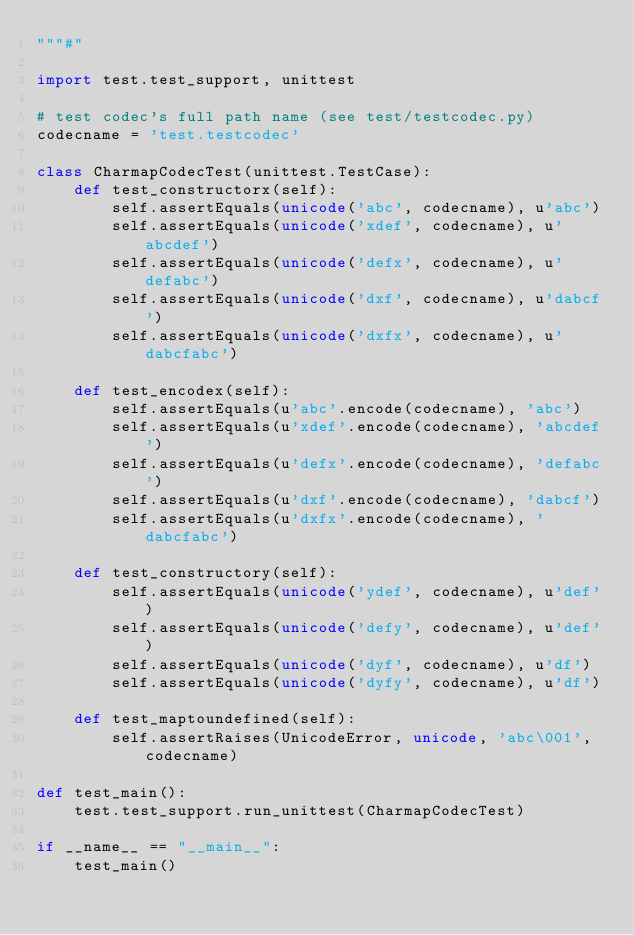<code> <loc_0><loc_0><loc_500><loc_500><_Python_>"""#"

import test.test_support, unittest

# test codec's full path name (see test/testcodec.py)
codecname = 'test.testcodec'

class CharmapCodecTest(unittest.TestCase):
    def test_constructorx(self):
        self.assertEquals(unicode('abc', codecname), u'abc')
        self.assertEquals(unicode('xdef', codecname), u'abcdef')
        self.assertEquals(unicode('defx', codecname), u'defabc')
        self.assertEquals(unicode('dxf', codecname), u'dabcf')
        self.assertEquals(unicode('dxfx', codecname), u'dabcfabc')

    def test_encodex(self):
        self.assertEquals(u'abc'.encode(codecname), 'abc')
        self.assertEquals(u'xdef'.encode(codecname), 'abcdef')
        self.assertEquals(u'defx'.encode(codecname), 'defabc')
        self.assertEquals(u'dxf'.encode(codecname), 'dabcf')
        self.assertEquals(u'dxfx'.encode(codecname), 'dabcfabc')

    def test_constructory(self):
        self.assertEquals(unicode('ydef', codecname), u'def')
        self.assertEquals(unicode('defy', codecname), u'def')
        self.assertEquals(unicode('dyf', codecname), u'df')
        self.assertEquals(unicode('dyfy', codecname), u'df')

    def test_maptoundefined(self):
        self.assertRaises(UnicodeError, unicode, 'abc\001', codecname)

def test_main():
    test.test_support.run_unittest(CharmapCodecTest)

if __name__ == "__main__":
    test_main()
</code> 